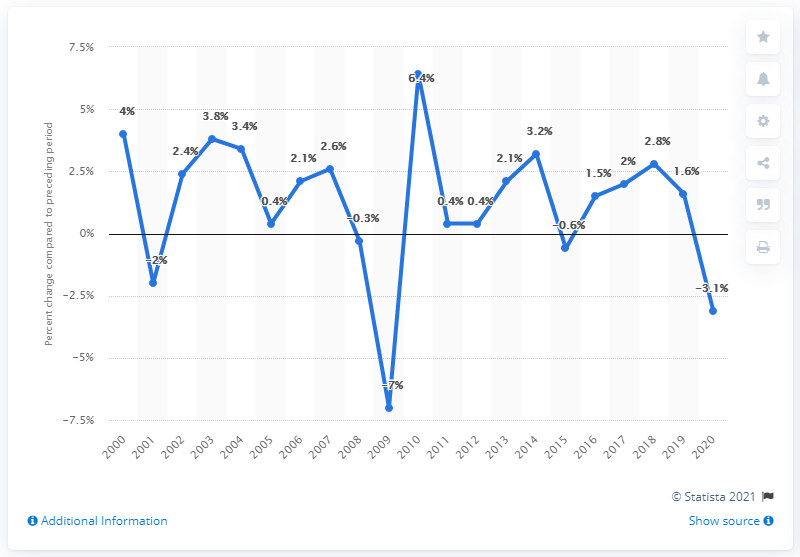Indicate a few pertinent items in this graphic. In 2010, the Gross Domestic Product (GDP) of the state of Indiana increased by 6.4% compared to the previous year. 